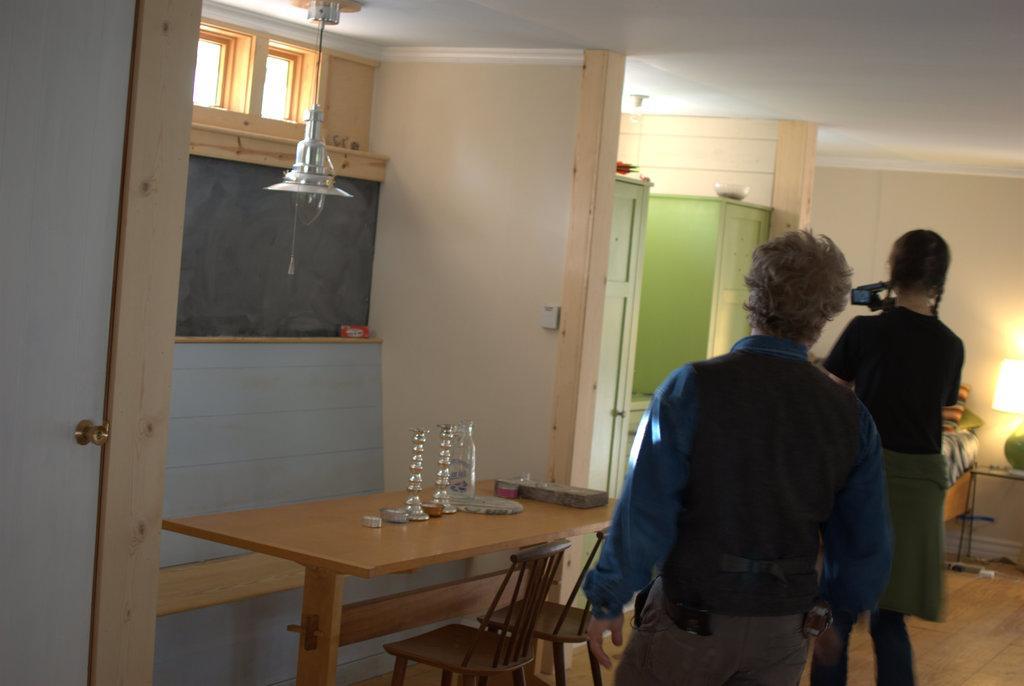How would you summarize this image in a sentence or two? These two persons are standing. This woman is holding a camera. On this table there is a bottle and things. In-front of this table there are chairs. On top there is a light attached to roof top. This is bed with pillows. Beside this bed there is a table, on this table there is a lantern lamp. Above this cupboard there is a bowl. 